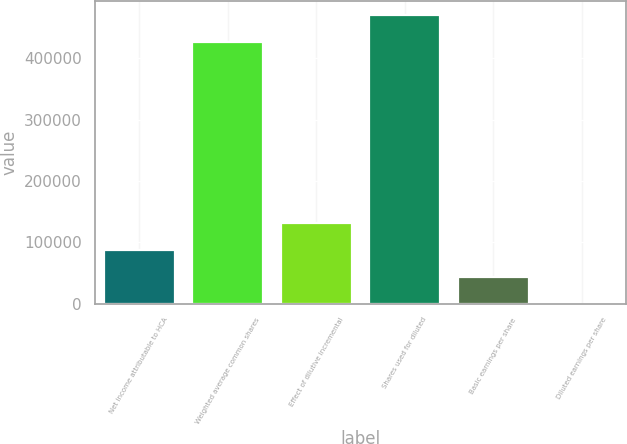<chart> <loc_0><loc_0><loc_500><loc_500><bar_chart><fcel>Net income attributable to HCA<fcel>Weighted average common shares<fcel>Effect of dilutive incremental<fcel>Shares used for diluted<fcel>Basic earnings per share<fcel>Diluted earnings per share<nl><fcel>87471.6<fcel>426424<fcel>131206<fcel>470158<fcel>43737.2<fcel>2.76<nl></chart> 